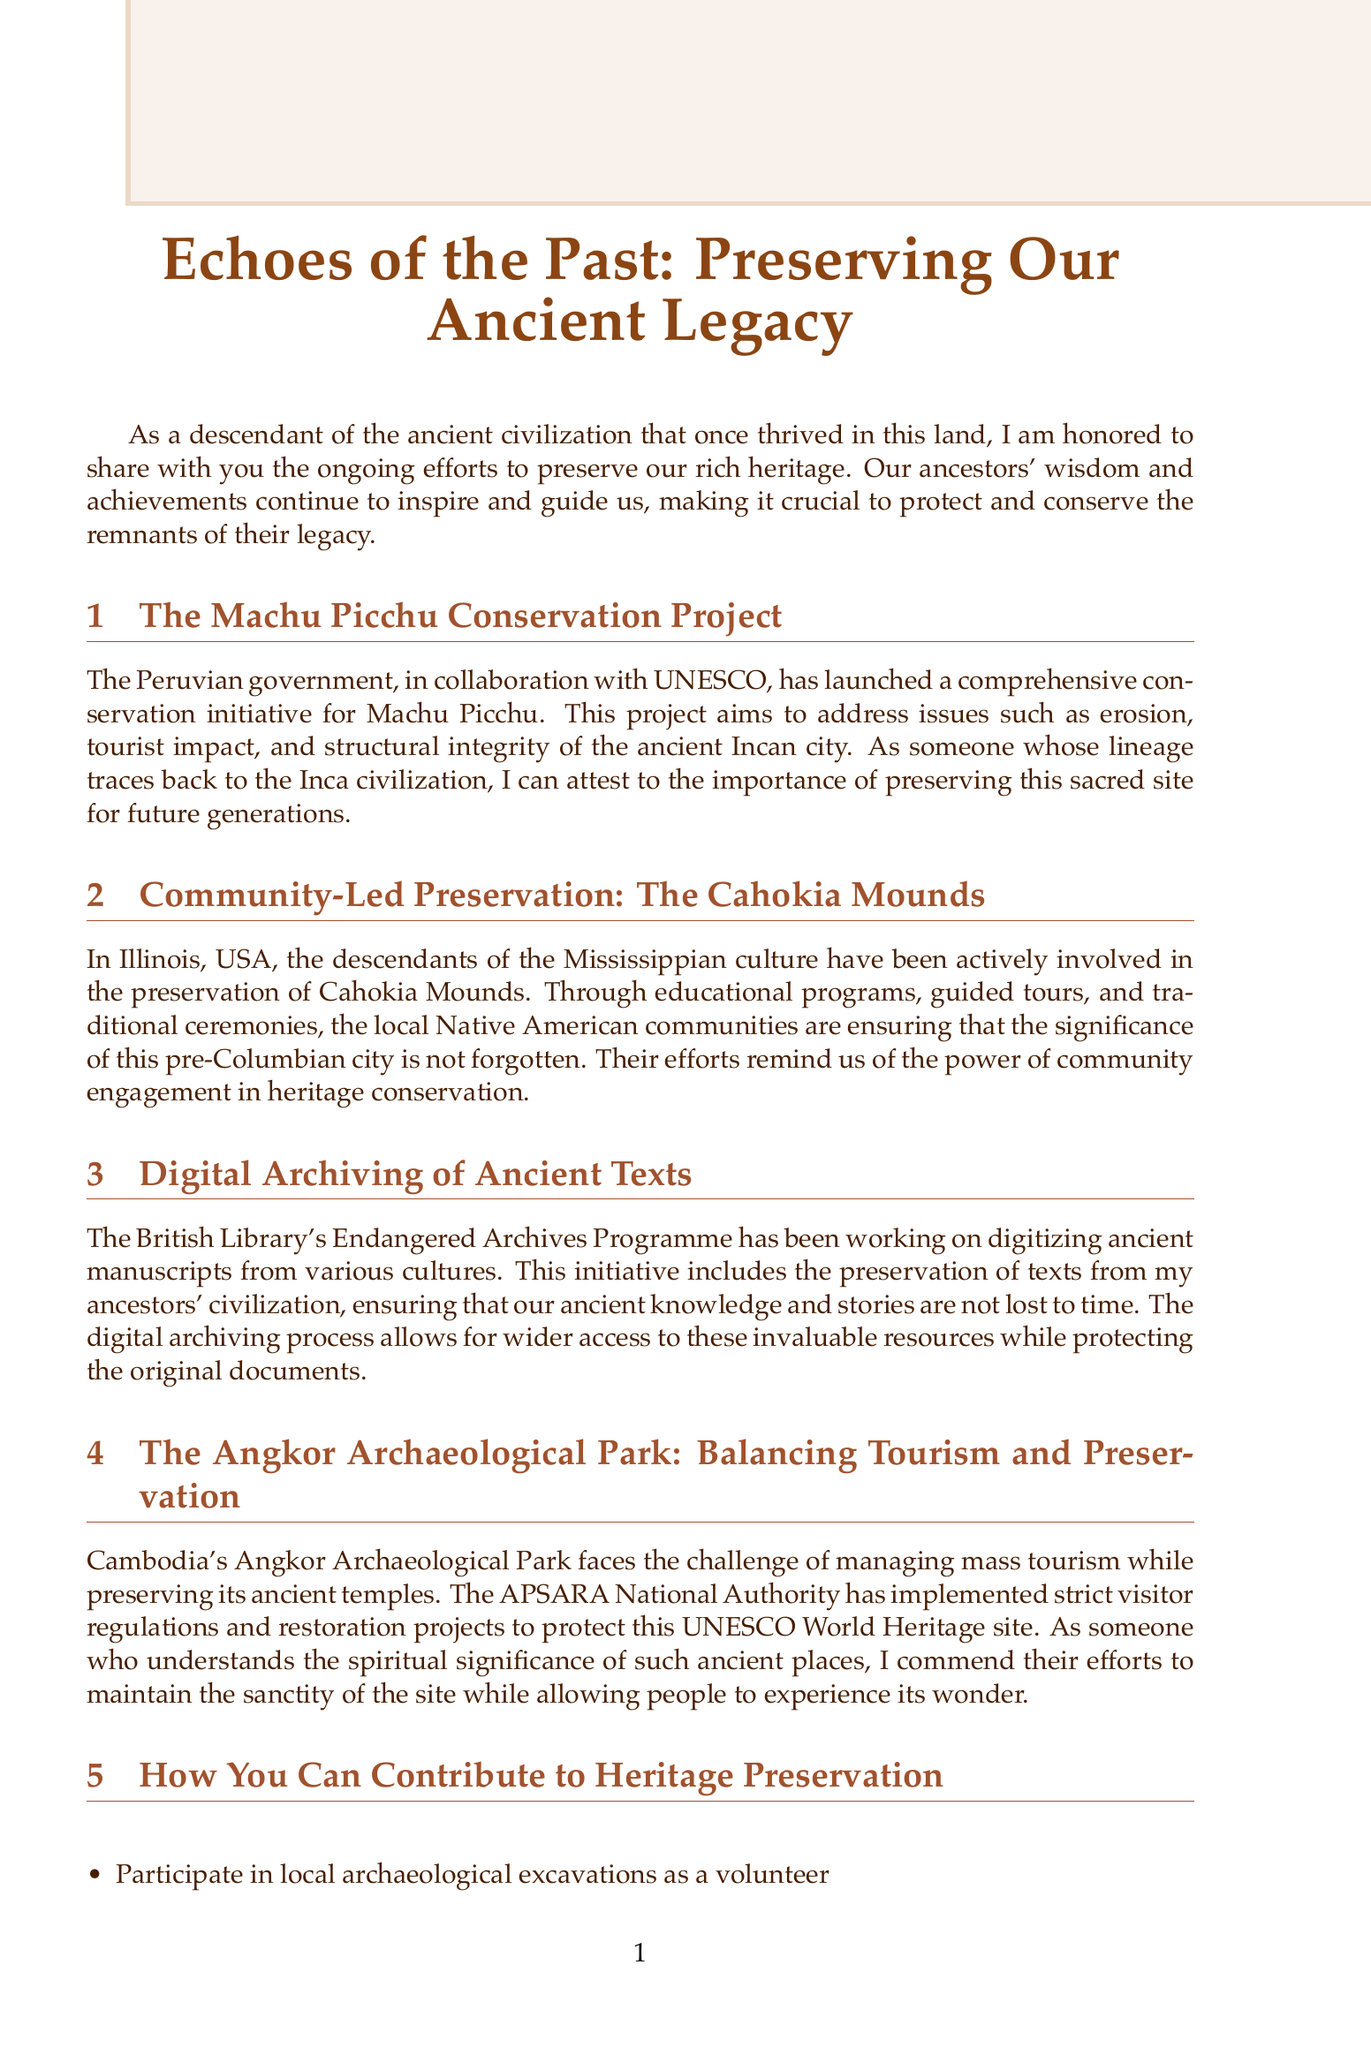What is the title of the newsletter? The title of the newsletter is explicitly stated at the beginning of the document.
Answer: Echoes of the Past: Preserving Our Ancient Legacy Who is collaborating with the Peruvian government for the Machu Picchu Conservation Project? It's mentioned that UNESCO is collaborating with the Peruvian government for this project.
Answer: UNESCO What ancient site is being discussed in the context of community-led preservation in Illinois, USA? The document specifies that the Cahokia Mounds are being preserved by the local communities.
Answer: Cahokia Mounds What program is digitizing ancient manuscripts? The British Library's Endangered Archives Programme is responsible for this digitization effort.
Answer: Endangered Archives Programme What does the APSARA National Authority manage? It is stated in the document that the APSARA National Authority manages the Angkor Archaeological Park.
Answer: Angkor Archaeological Park How can individuals contribute to heritage preservation? The document lists several ways, one of which is participating in local archaeological excavations.
Answer: Participate in local archaeological excavations as a volunteer What is the author's name? The author's name is provided in the about section towards the end of the document.
Answer: Amaru Yupanqui What type of engagement is highlighted in the preservation of the Cahokia Mounds? Community engagement is emphasized as essential for this preservation effort.
Answer: Community engagement What is the significance of digital archiving mentioned in the newsletter? The document notes that digital archiving allows for wider access while protecting original documents.
Answer: Wider access to invaluable resources 